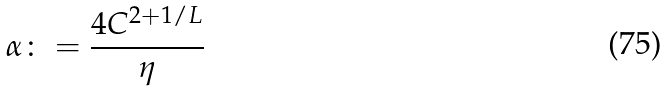Convert formula to latex. <formula><loc_0><loc_0><loc_500><loc_500>\alpha \colon = \frac { 4 C ^ { 2 + 1 / L } } { \eta }</formula> 